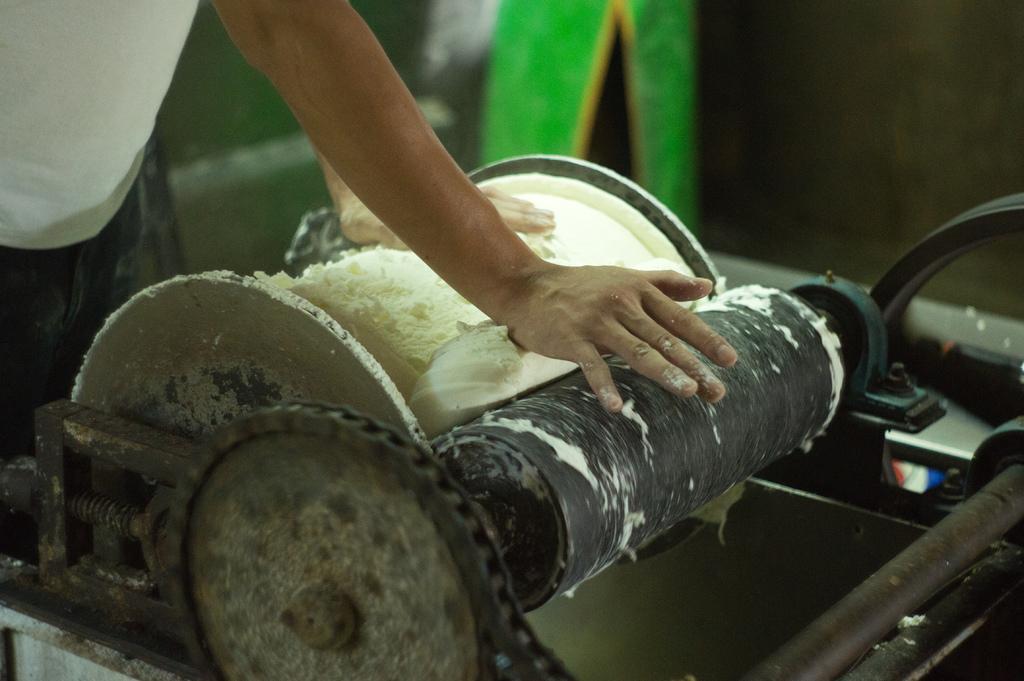Describe this image in one or two sentences. In the top left corner of the image a person is standing and holding a machine. 